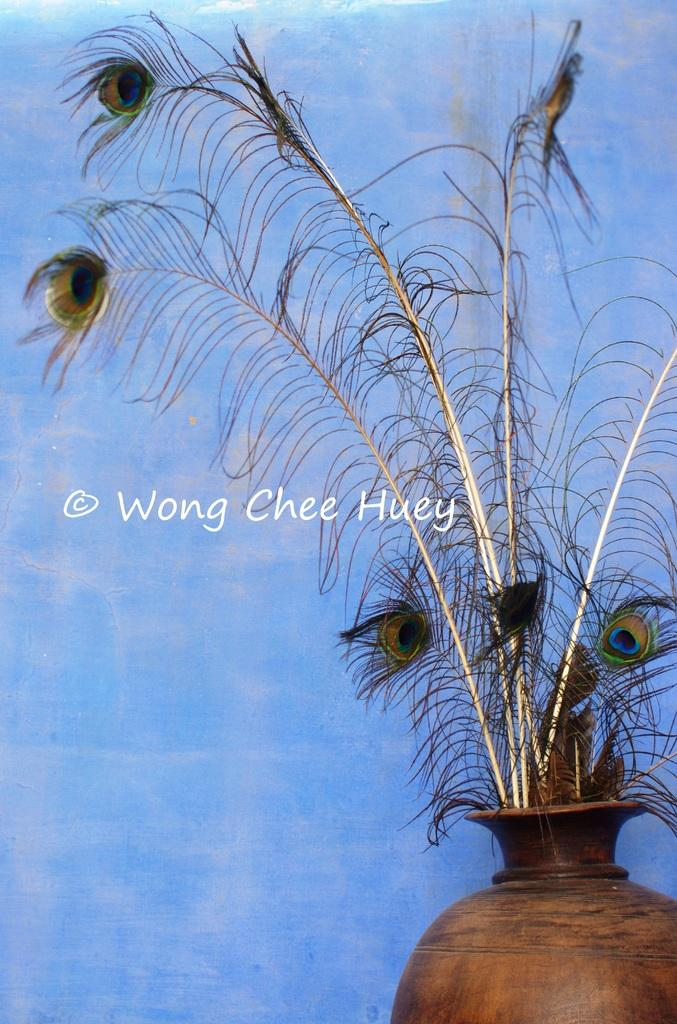What object can be seen in the image? There is a vase in the image. What is depicted on the vase? There are many feathers of the peacock on the vase. What is located at the center of the image? There is some text at the center of the image. What color is the background of the image? The background of the image is blue. How many boats are visible in the image? There are no boats present in the image. What type of approval is being sought in the image? There is no indication of approval being sought in the image. 